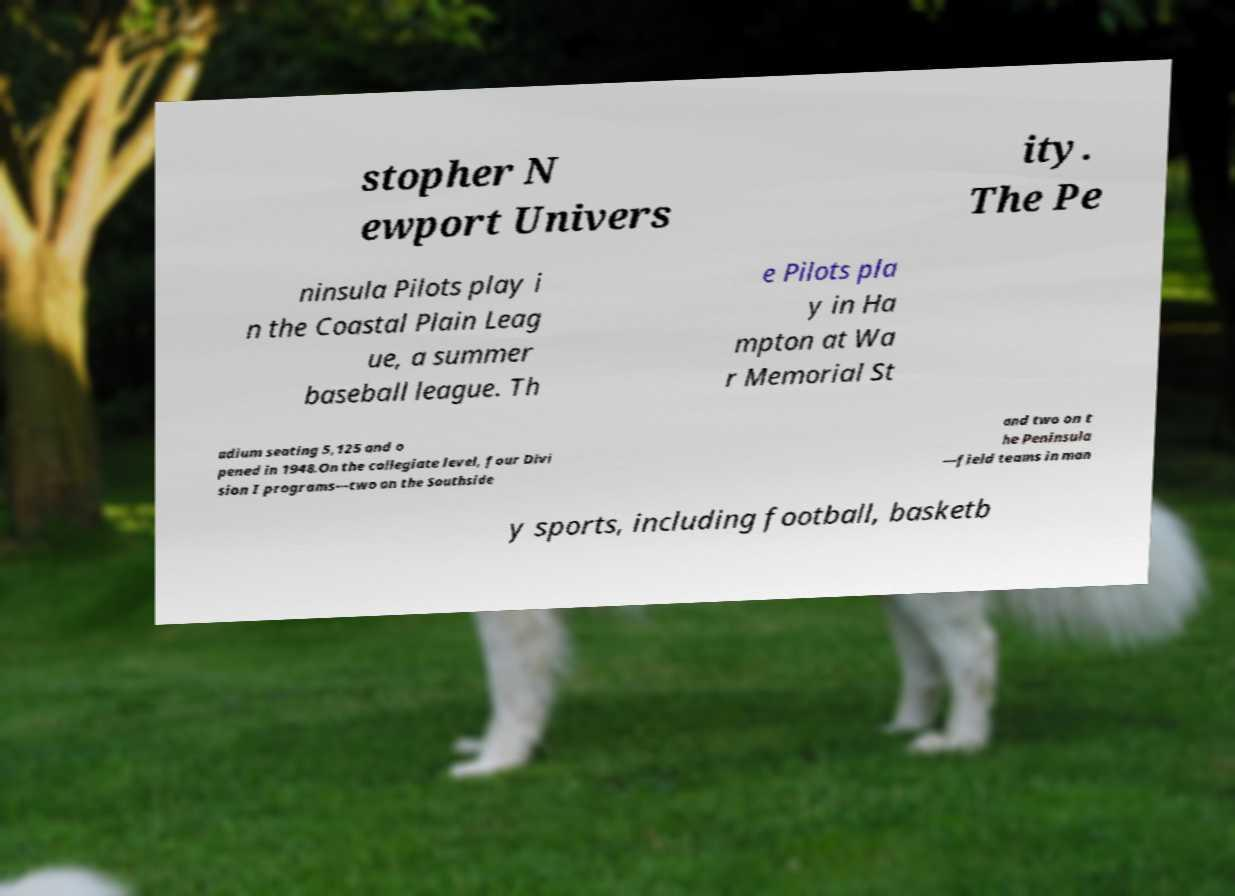For documentation purposes, I need the text within this image transcribed. Could you provide that? stopher N ewport Univers ity. The Pe ninsula Pilots play i n the Coastal Plain Leag ue, a summer baseball league. Th e Pilots pla y in Ha mpton at Wa r Memorial St adium seating 5,125 and o pened in 1948.On the collegiate level, four Divi sion I programs—two on the Southside and two on t he Peninsula —field teams in man y sports, including football, basketb 